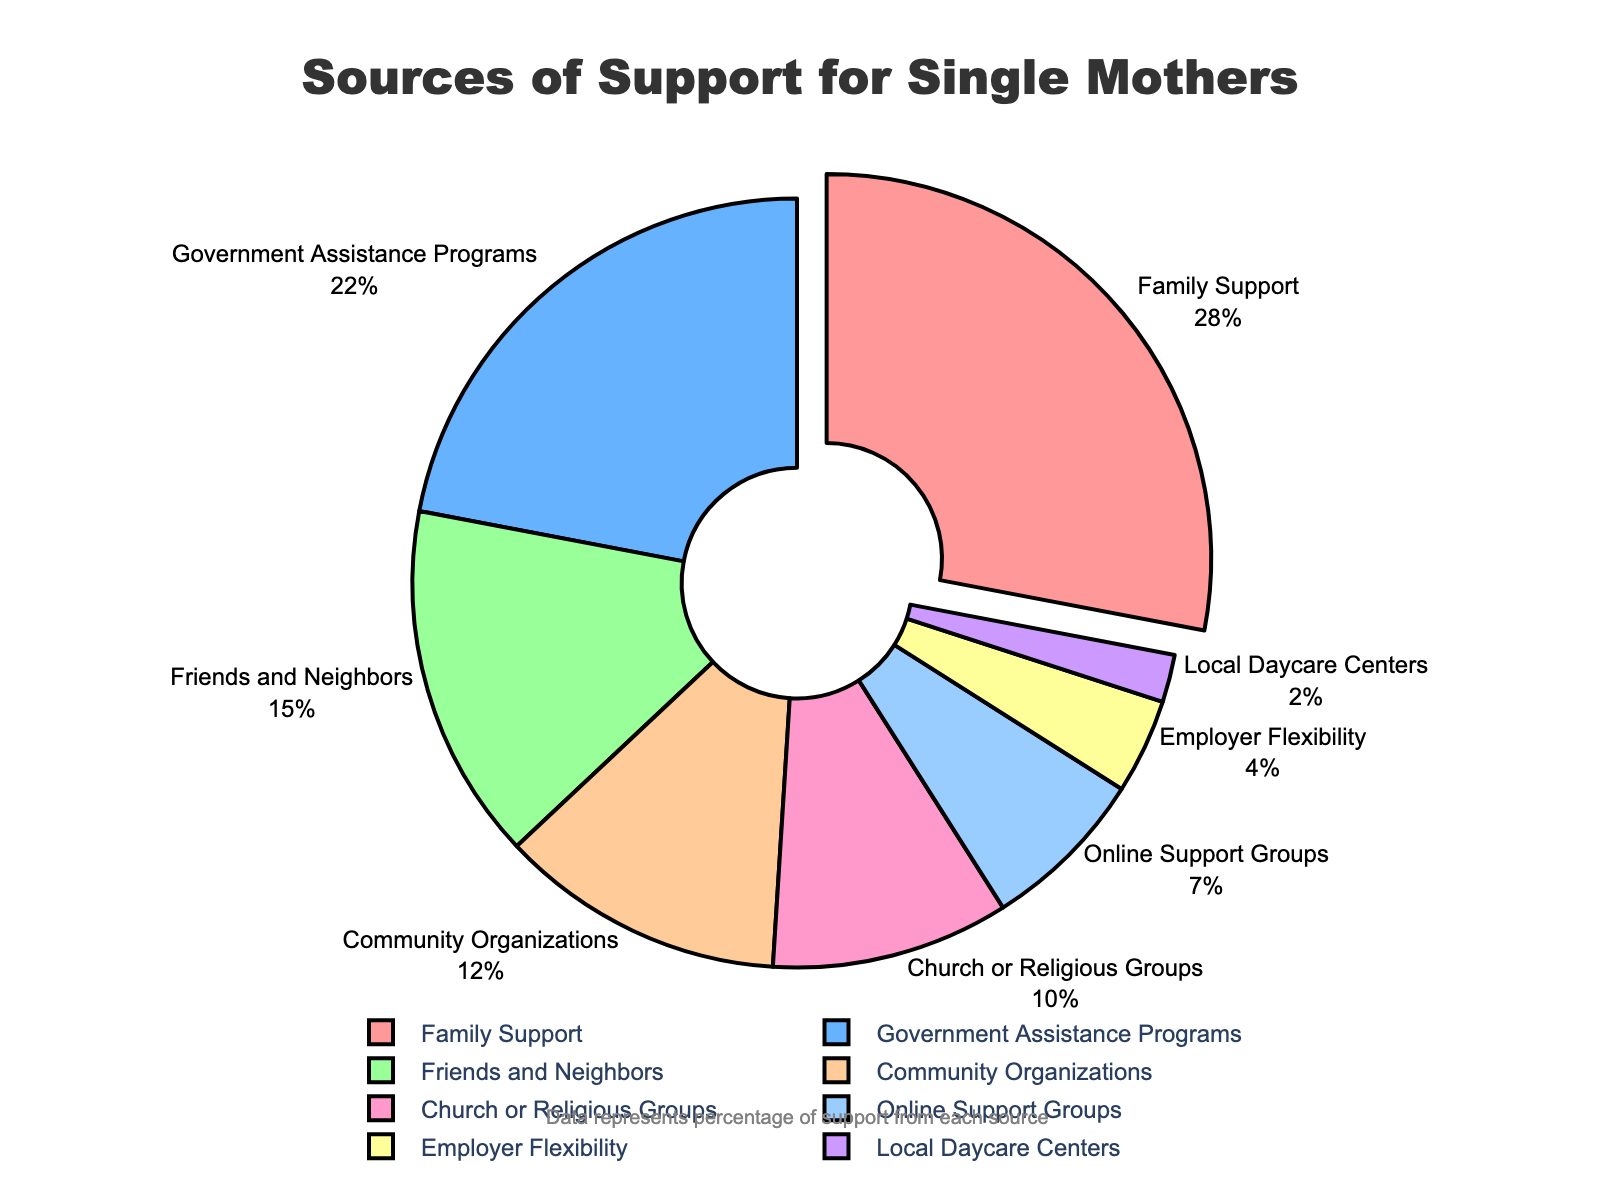Which source provides the most support for single mothers? The largest segment on the pie chart represents the source of support that provides the most. Family Support accounts for 28% of the total support.
Answer: Family Support Which provides more support, Community Organizations or Online Support Groups? Comparing the two segments, Community Organizations provide 12% while Online Support Groups provide 7%.
Answer: Community Organizations What's the total percentage of support from Family Support and Government Assistance Programs combined? Adding the percentages: Family Support (28%) + Government Assistance Programs (22%) = 28% + 22% = 50%
Answer: 50% Which sources provide less than 10% support? Observing the segments with less than 10%, we identify Online Support Groups (7%), Employer Flexibility (4%), and Local Daycare Centers (2%).
Answer: Online Support Groups, Employer Flexibility, Local Daycare Centers What source has the smallest portion of support, and what percentage does it represent? The smallest segment is identified: Local Daycare Centers with 2% support.
Answer: Local Daycare Centers, 2% How much more support does Friends and Neighbors provide compared to Employer Flexibility? The difference is calculated: Friends and Neighbors (15%) - Employer Flexibility (4%) = 15% - 4% = 11%
Answer: 11% What is the combined percentage of the smallest three sources of support? Summing the smallest three percentages: Online Support Groups (7%) + Employer Flexibility (4%) + Local Daycare Centers (2%) = 7% + 4% + 2% = 13%
Answer: 13% What percentage of support is provided by Church or Religious Groups compared to Government Assistance Programs? Comparing the percentages: Church or Religious Groups (10%) and Government Assistance Programs (22%) shows Government Assistance Programs provide more.
Answer: 10%, 22% Which segments account for more than 20% of the support? Identifying segments over 20%: Family Support (28%) and Government Assistance Programs (22%) are the only ones over 20%.
Answer: Family Support, Government Assistance Programs What is the total percentage of support provided by sources related to family and friends (i.e., Family Support and Friends and Neighbors)? Adding the percentages: Family Support (28%) + Friends and Neighbors (15%) = 28% + 15% = 43%
Answer: 43% 